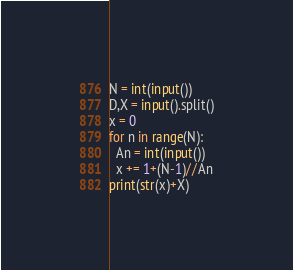<code> <loc_0><loc_0><loc_500><loc_500><_Python_>N = int(input())
D,X = input().split()
x = 0
for n in range(N):
  An = int(input())
  x += 1+(N-1)//An
print(str(x)+X)
</code> 